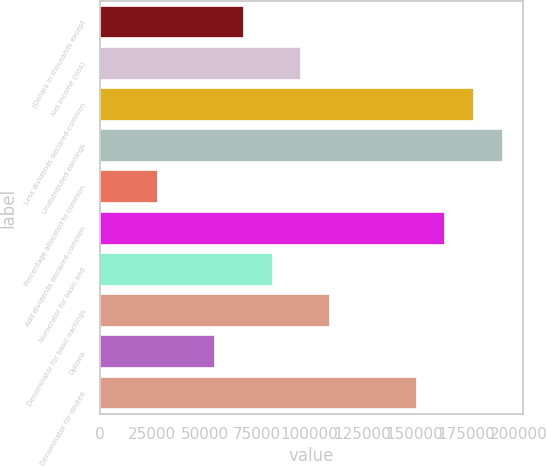<chart> <loc_0><loc_0><loc_500><loc_500><bar_chart><fcel>(Dollars in thousands except<fcel>Net income (loss)<fcel>Less dividends declared-common<fcel>Undistributed earnings<fcel>Percentage allocated to common<fcel>Add dividends declared-common<fcel>Numerator for basic and<fcel>Denominator for basic earnings<fcel>Options<fcel>Denominator for diluted<nl><fcel>68687.6<fcel>96162.6<fcel>178587<fcel>192325<fcel>27475.2<fcel>164850<fcel>82425.1<fcel>109900<fcel>54950.2<fcel>151112<nl></chart> 